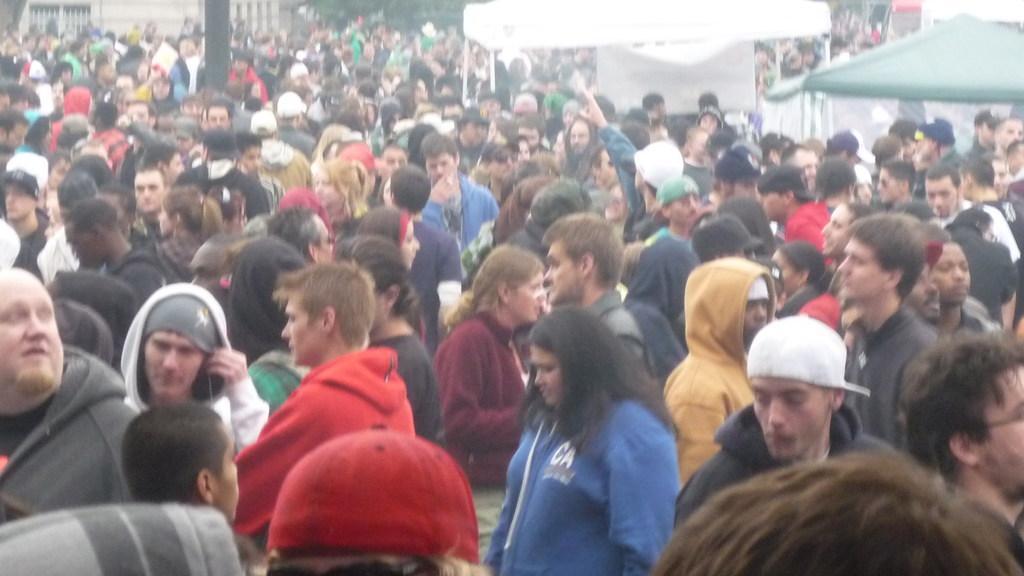How would you summarize this image in a sentence or two? In the image there is a huge crowd and on the right side there is a shelter in between the crowd and behind that shelter there is a white color roof. 